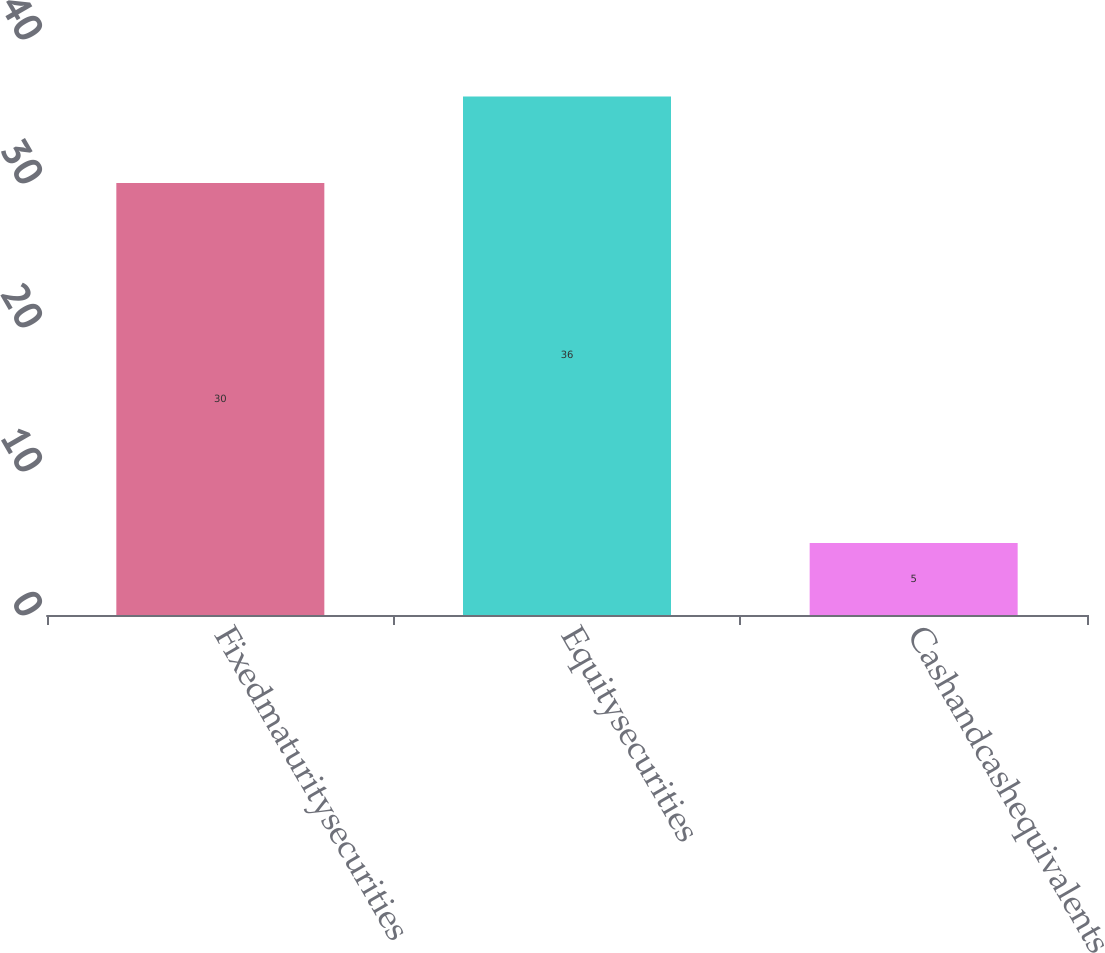Convert chart to OTSL. <chart><loc_0><loc_0><loc_500><loc_500><bar_chart><fcel>Fixedmaturitysecurities<fcel>Equitysecurities<fcel>Cashandcashequivalents<nl><fcel>30<fcel>36<fcel>5<nl></chart> 